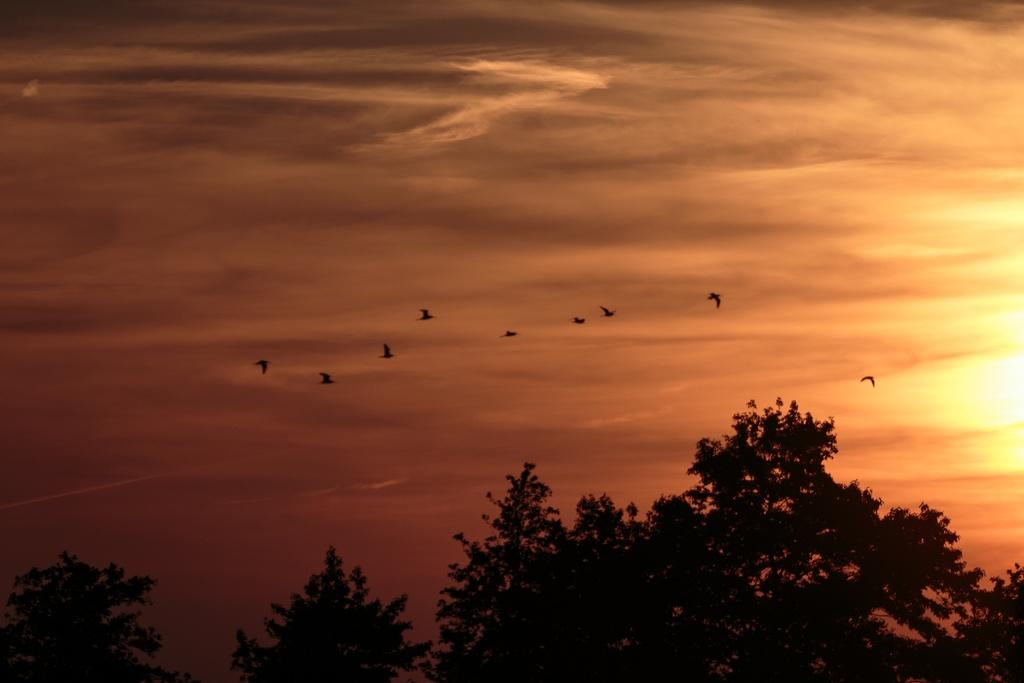What type of vegetation can be seen in the image? There are trees in the image. What animals are visible in the image? There are birds flying in the air in the image. What part of the natural environment is visible in the image? The sky is visible in the image. What type of fairies can be seen teaching a game in the image? There are no fairies or any indication of teaching or a game present in the image. 